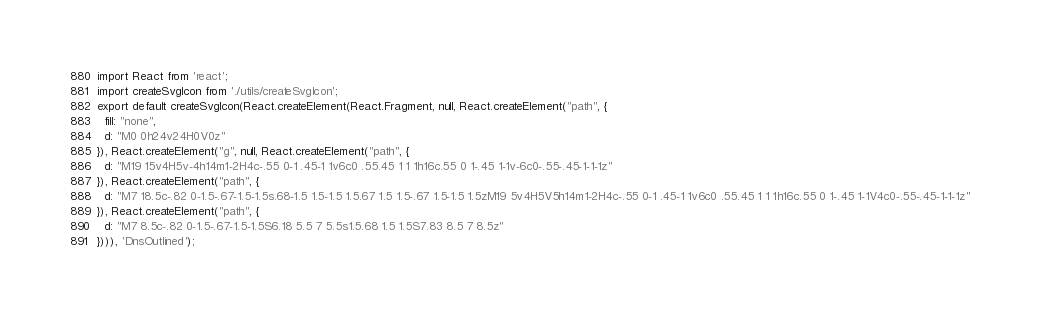<code> <loc_0><loc_0><loc_500><loc_500><_JavaScript_>import React from 'react';
import createSvgIcon from './utils/createSvgIcon';
export default createSvgIcon(React.createElement(React.Fragment, null, React.createElement("path", {
  fill: "none",
  d: "M0 0h24v24H0V0z"
}), React.createElement("g", null, React.createElement("path", {
  d: "M19 15v4H5v-4h14m1-2H4c-.55 0-1 .45-1 1v6c0 .55.45 1 1 1h16c.55 0 1-.45 1-1v-6c0-.55-.45-1-1-1z"
}), React.createElement("path", {
  d: "M7 18.5c-.82 0-1.5-.67-1.5-1.5s.68-1.5 1.5-1.5 1.5.67 1.5 1.5-.67 1.5-1.5 1.5zM19 5v4H5V5h14m1-2H4c-.55 0-1 .45-1 1v6c0 .55.45 1 1 1h16c.55 0 1-.45 1-1V4c0-.55-.45-1-1-1z"
}), React.createElement("path", {
  d: "M7 8.5c-.82 0-1.5-.67-1.5-1.5S6.18 5.5 7 5.5s1.5.68 1.5 1.5S7.83 8.5 7 8.5z"
}))), 'DnsOutlined');</code> 